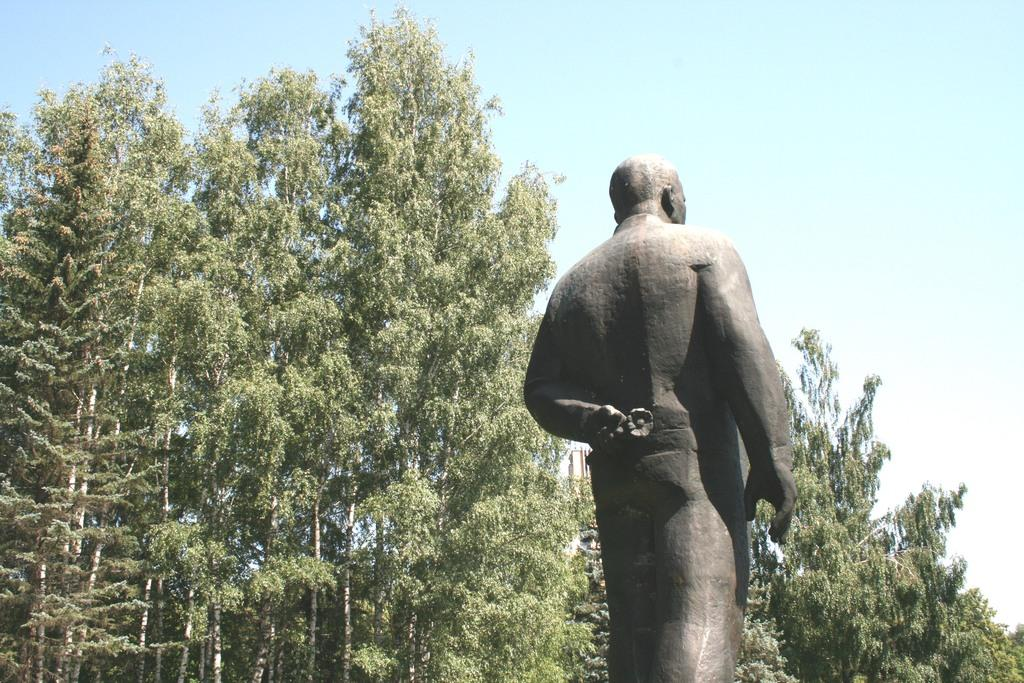What is the main subject of the image? There is a statue of a person in the image. What can be seen in the background of the image? There are trees and the sky visible in the background of the image. What type of desk is visible in the image? There is no desk present in the image. How does the statue contribute to the growth of the trees in the image? The statue does not contribute to the growth of the trees in the image; it is a separate object in the scene. 